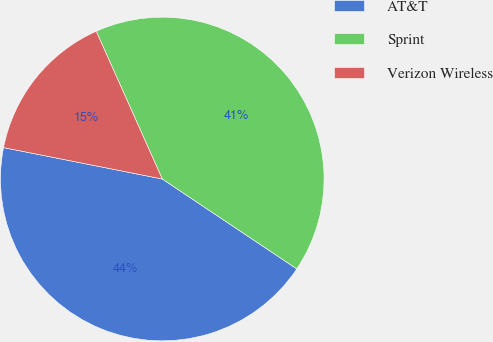<chart> <loc_0><loc_0><loc_500><loc_500><pie_chart><fcel>AT&T<fcel>Sprint<fcel>Verizon Wireless<nl><fcel>43.73%<fcel>41.07%<fcel>15.2%<nl></chart> 